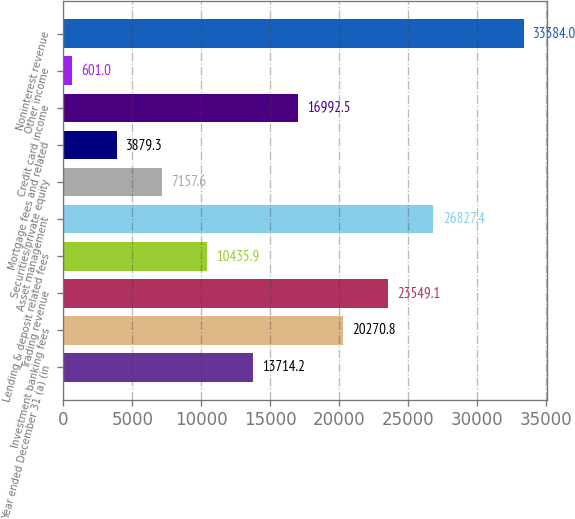Convert chart. <chart><loc_0><loc_0><loc_500><loc_500><bar_chart><fcel>Year ended December 31 (a) (in<fcel>Investment banking fees<fcel>Trading revenue<fcel>Lending & deposit related fees<fcel>Asset management<fcel>Securities/private equity<fcel>Mortgage fees and related<fcel>Credit card income<fcel>Other income<fcel>Noninterest revenue<nl><fcel>13714.2<fcel>20270.8<fcel>23549.1<fcel>10435.9<fcel>26827.4<fcel>7157.6<fcel>3879.3<fcel>16992.5<fcel>601<fcel>33384<nl></chart> 